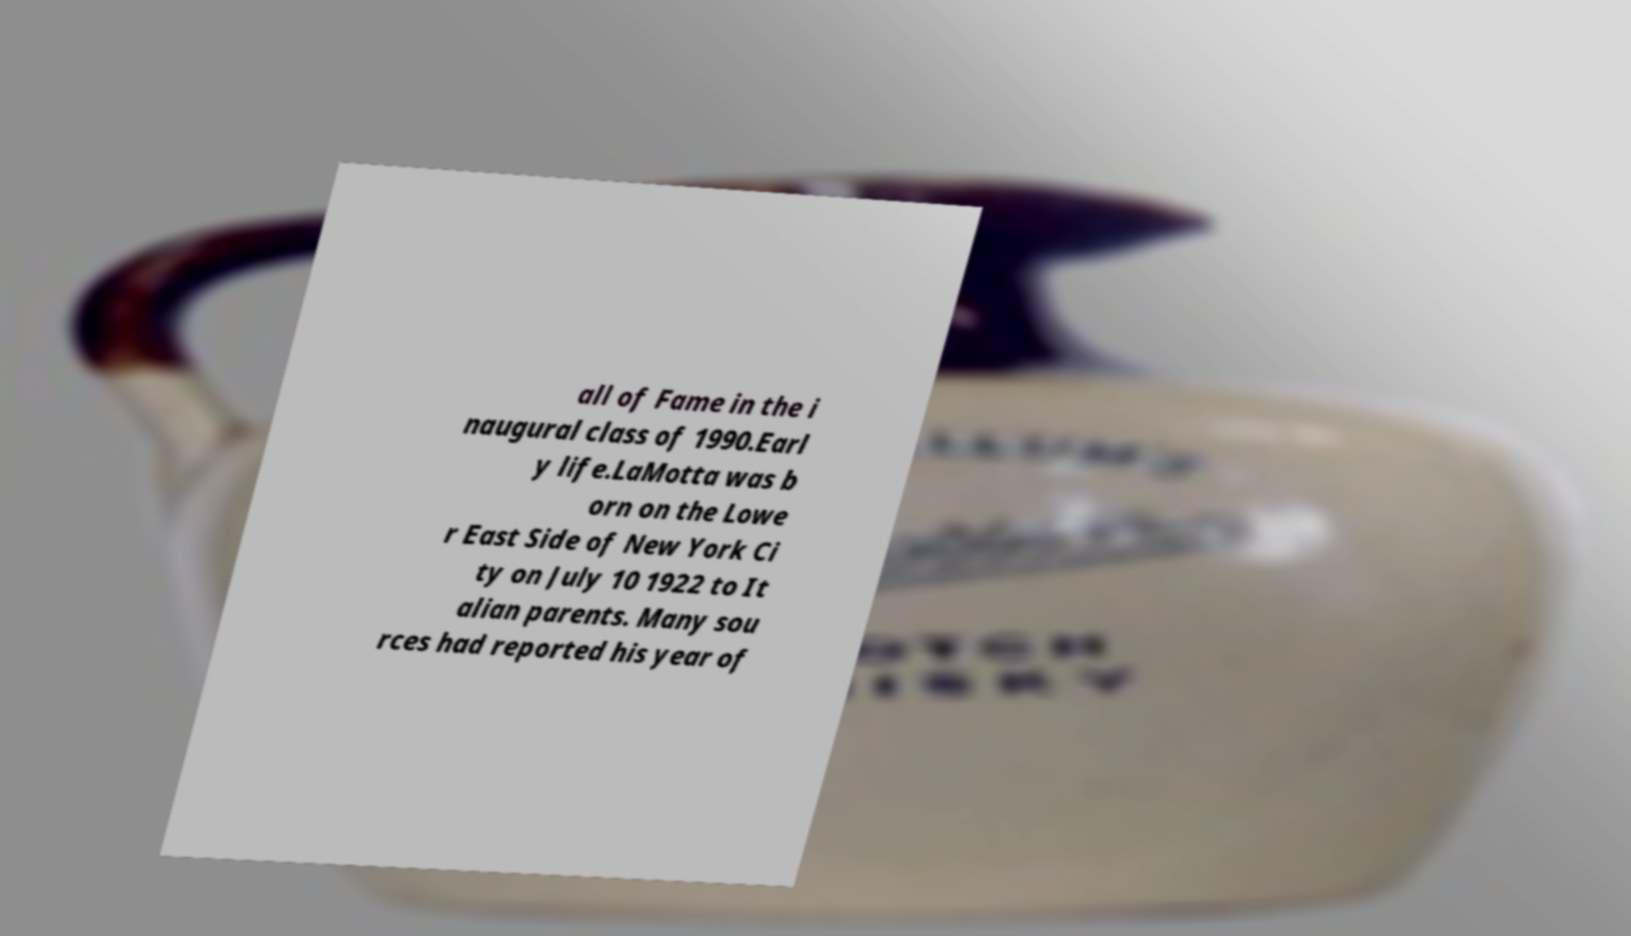There's text embedded in this image that I need extracted. Can you transcribe it verbatim? all of Fame in the i naugural class of 1990.Earl y life.LaMotta was b orn on the Lowe r East Side of New York Ci ty on July 10 1922 to It alian parents. Many sou rces had reported his year of 